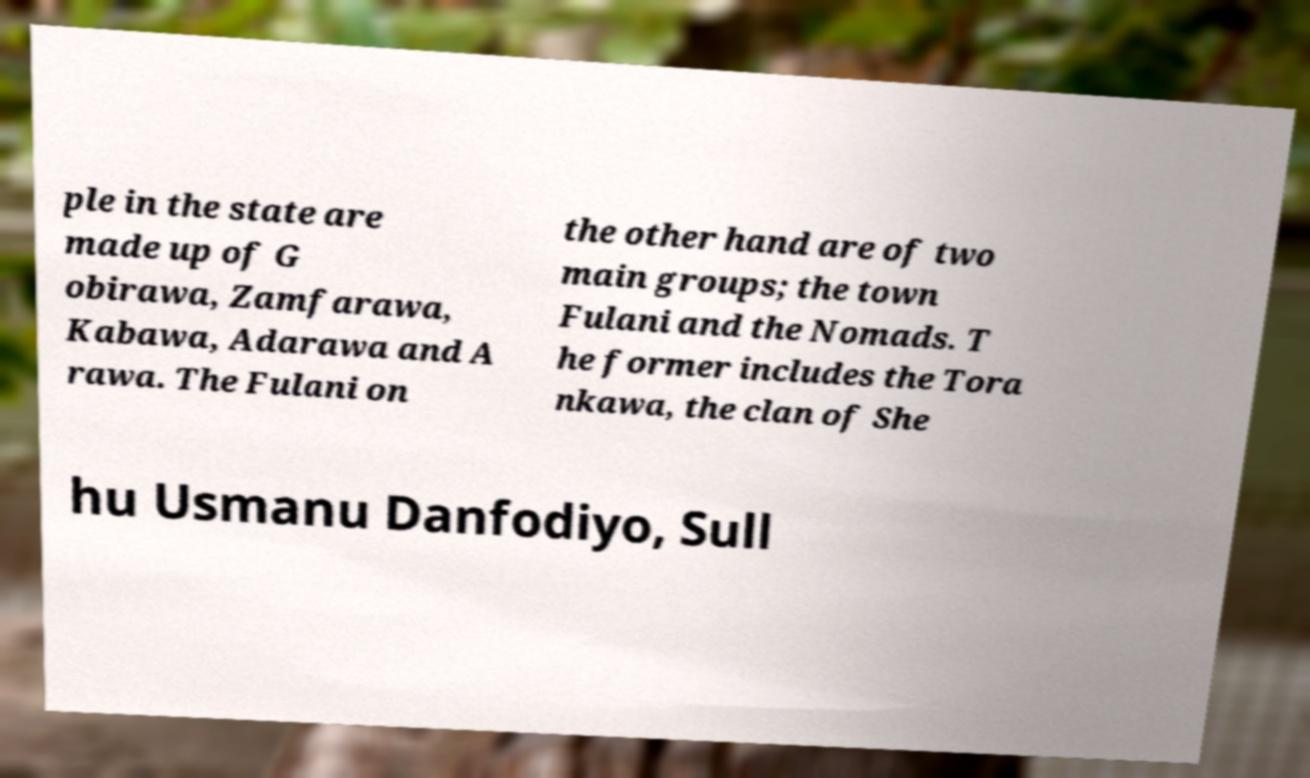For documentation purposes, I need the text within this image transcribed. Could you provide that? ple in the state are made up of G obirawa, Zamfarawa, Kabawa, Adarawa and A rawa. The Fulani on the other hand are of two main groups; the town Fulani and the Nomads. T he former includes the Tora nkawa, the clan of She hu Usmanu Danfodiyo, Sull 